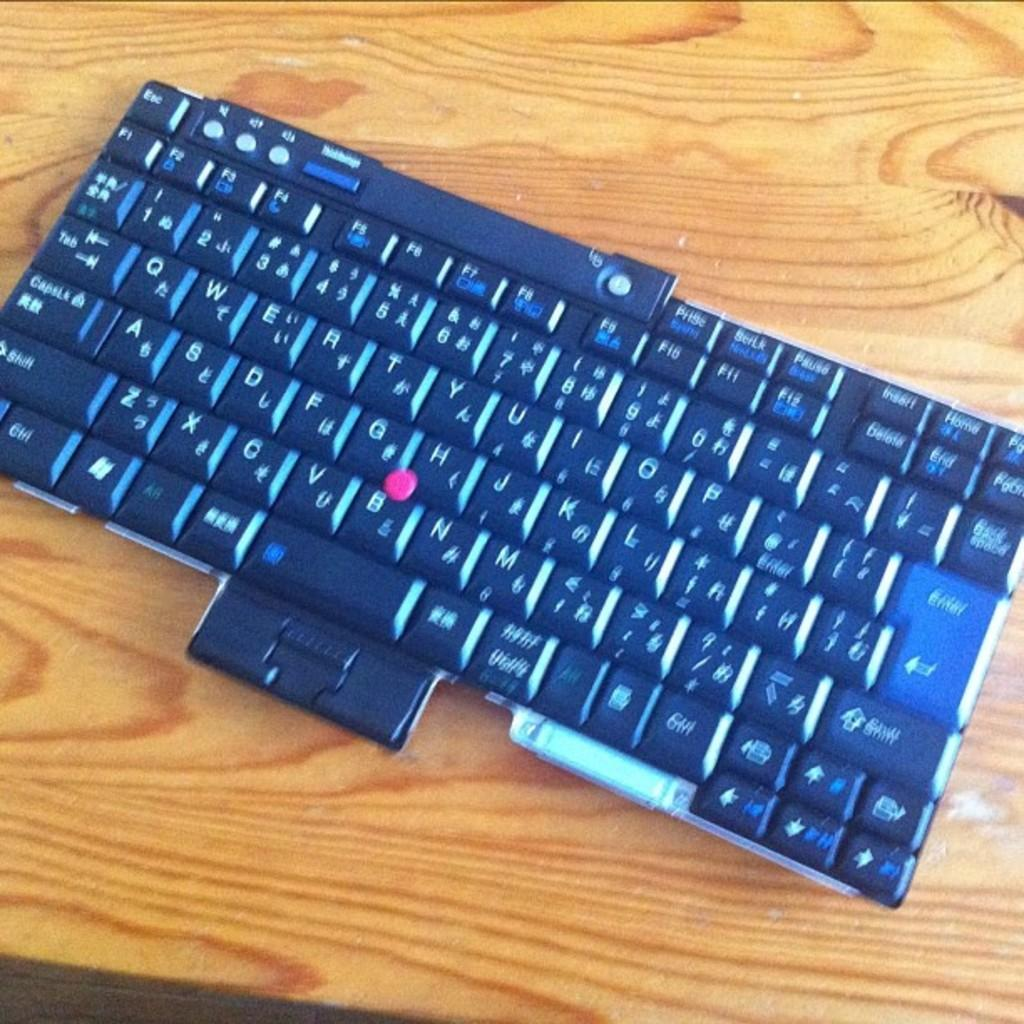<image>
Present a compact description of the photo's key features. A black keyboard sits on the table on its own showing all numbers and letters including h,j, k, l 